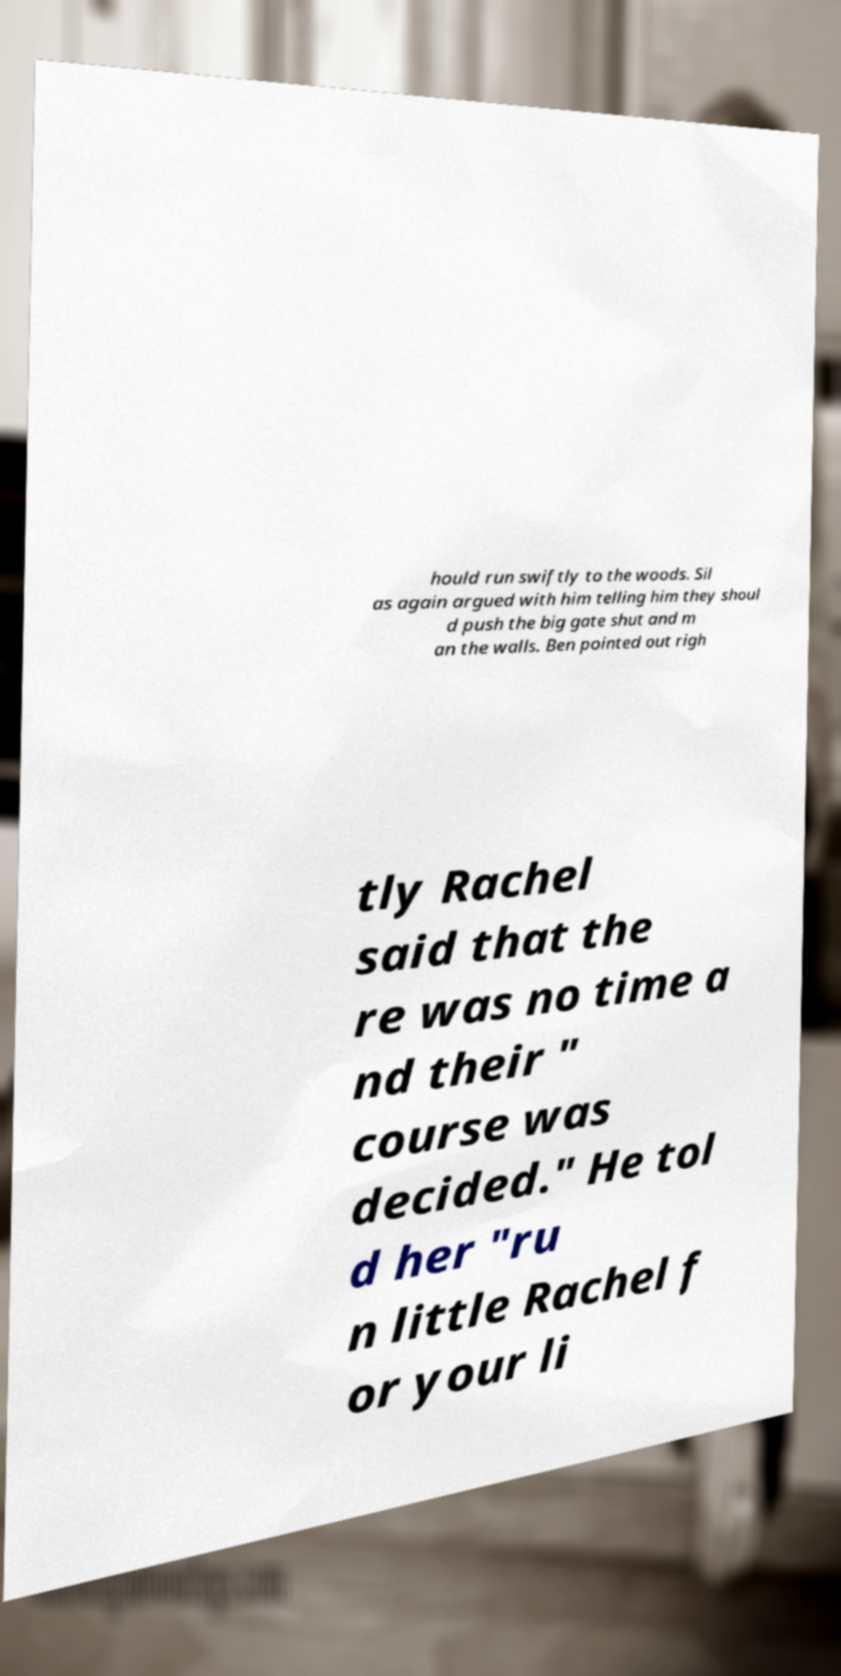I need the written content from this picture converted into text. Can you do that? hould run swiftly to the woods. Sil as again argued with him telling him they shoul d push the big gate shut and m an the walls. Ben pointed out righ tly Rachel said that the re was no time a nd their " course was decided." He tol d her "ru n little Rachel f or your li 